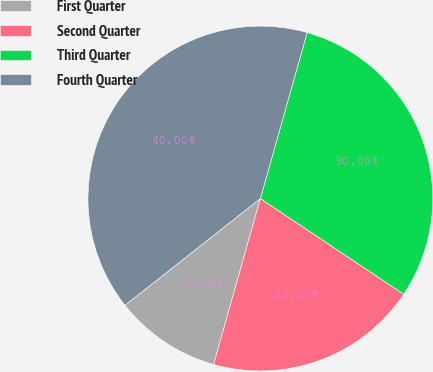<chart> <loc_0><loc_0><loc_500><loc_500><pie_chart><fcel>First Quarter<fcel>Second Quarter<fcel>Third Quarter<fcel>Fourth Quarter<nl><fcel>10.0%<fcel>20.0%<fcel>30.0%<fcel>40.0%<nl></chart> 